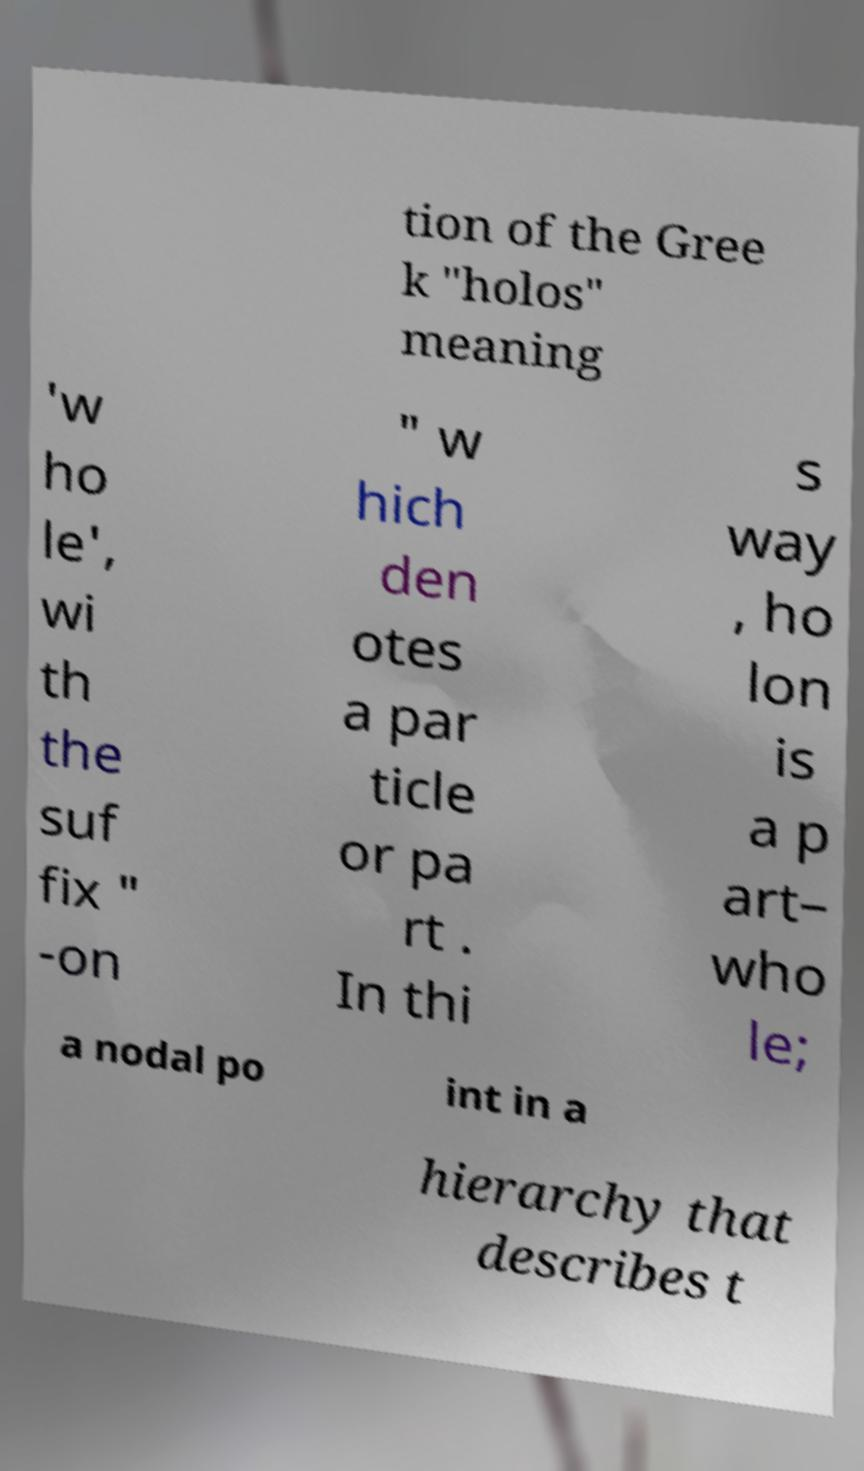What messages or text are displayed in this image? I need them in a readable, typed format. tion of the Gree k "holos" meaning 'w ho le', wi th the suf fix " -on " w hich den otes a par ticle or pa rt . In thi s way , ho lon is a p art– who le; a nodal po int in a hierarchy that describes t 